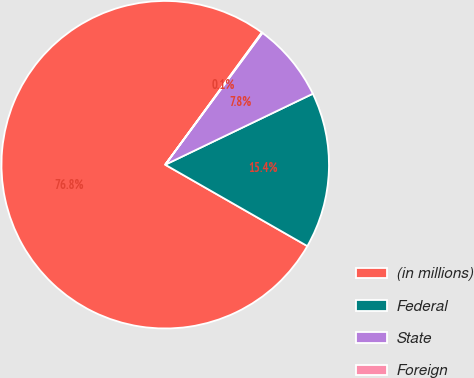<chart> <loc_0><loc_0><loc_500><loc_500><pie_chart><fcel>(in millions)<fcel>Federal<fcel>State<fcel>Foreign<nl><fcel>76.76%<fcel>15.41%<fcel>7.75%<fcel>0.08%<nl></chart> 